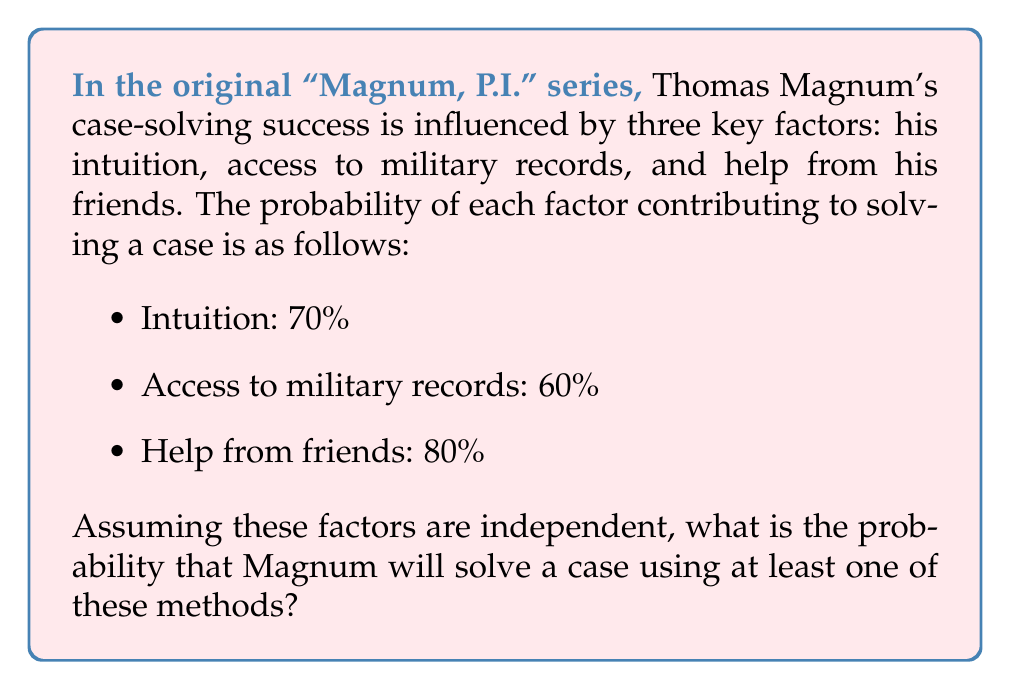Help me with this question. To solve this problem, we'll use the concept of probability of the union of events. We need to find the probability of at least one event occurring, which is equivalent to 1 minus the probability of none of the events occurring.

Let's define our events:
A: Magnum solves the case using intuition
B: Magnum solves the case using access to military records
C: Magnum solves the case with help from friends

Given probabilities:
P(A) = 0.70
P(B) = 0.60
P(C) = 0.80

We want to find P(A ∪ B ∪ C), which is equal to 1 - P(not A and not B and not C)

Step 1: Calculate the probability of each event not occurring
P(not A) = 1 - P(A) = 1 - 0.70 = 0.30
P(not B) = 1 - P(B) = 1 - 0.60 = 0.40
P(not C) = 1 - P(C) = 1 - 0.80 = 0.20

Step 2: Calculate the probability of none of the events occurring
P(not A and not B and not C) = P(not A) × P(not B) × P(not C)
                               = 0.30 × 0.40 × 0.20
                               = 0.024

Step 3: Calculate the probability of at least one event occurring
P(A ∪ B ∪ C) = 1 - P(not A and not B and not C)
              = 1 - 0.024
              = 0.976

Therefore, the probability that Magnum will solve a case using at least one of these methods is 0.976 or 97.6%.
Answer: The probability that Magnum will solve a case using at least one of these methods is 0.976 or 97.6%. 